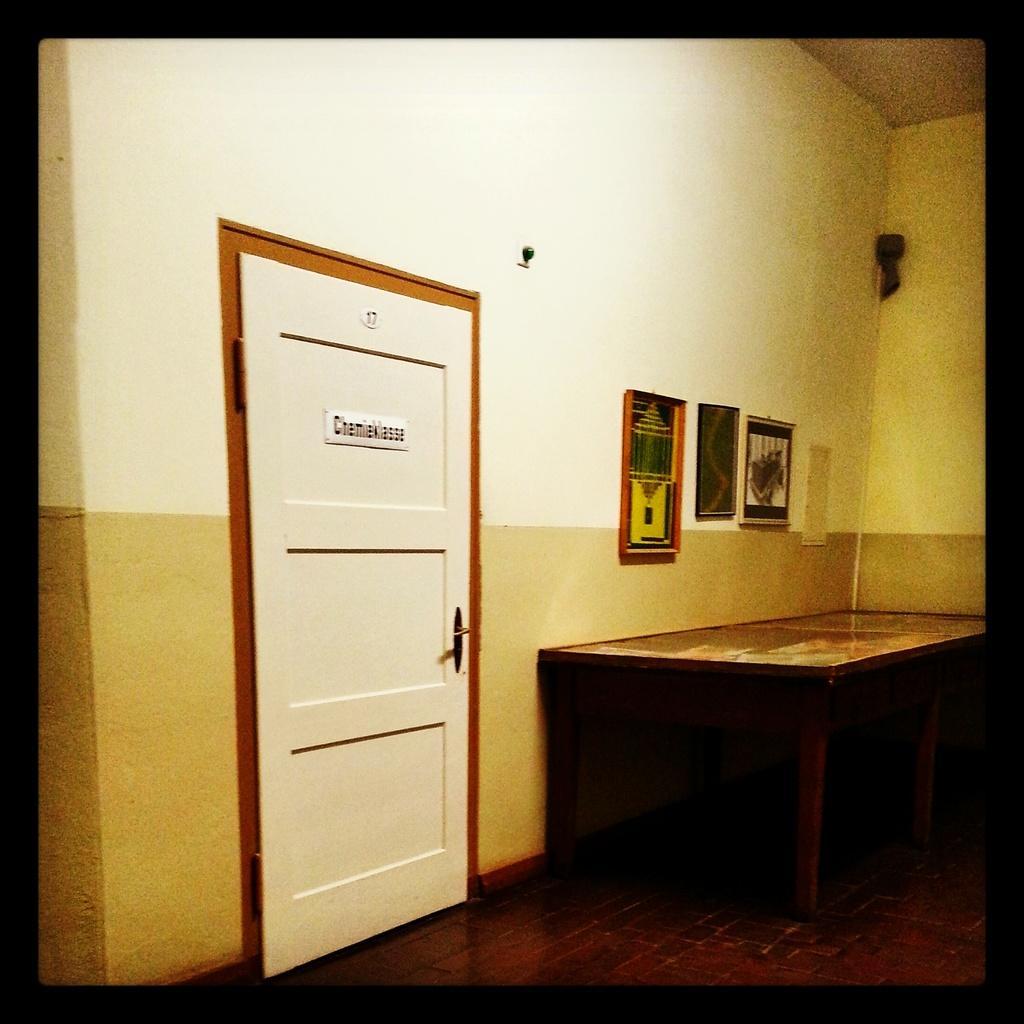Can you describe this image briefly? In this image, we can see a table, door and some frames on the wall and we can see some other objects. At the bottom, there is floor. 